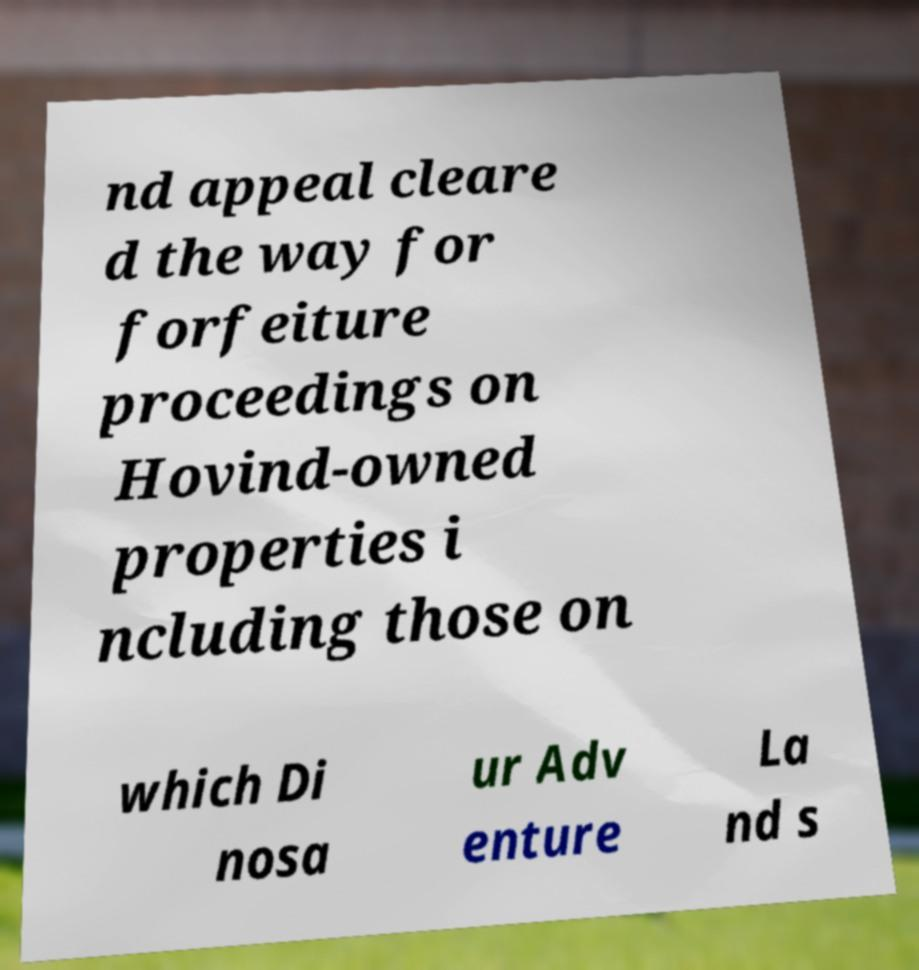Could you extract and type out the text from this image? nd appeal cleare d the way for forfeiture proceedings on Hovind-owned properties i ncluding those on which Di nosa ur Adv enture La nd s 